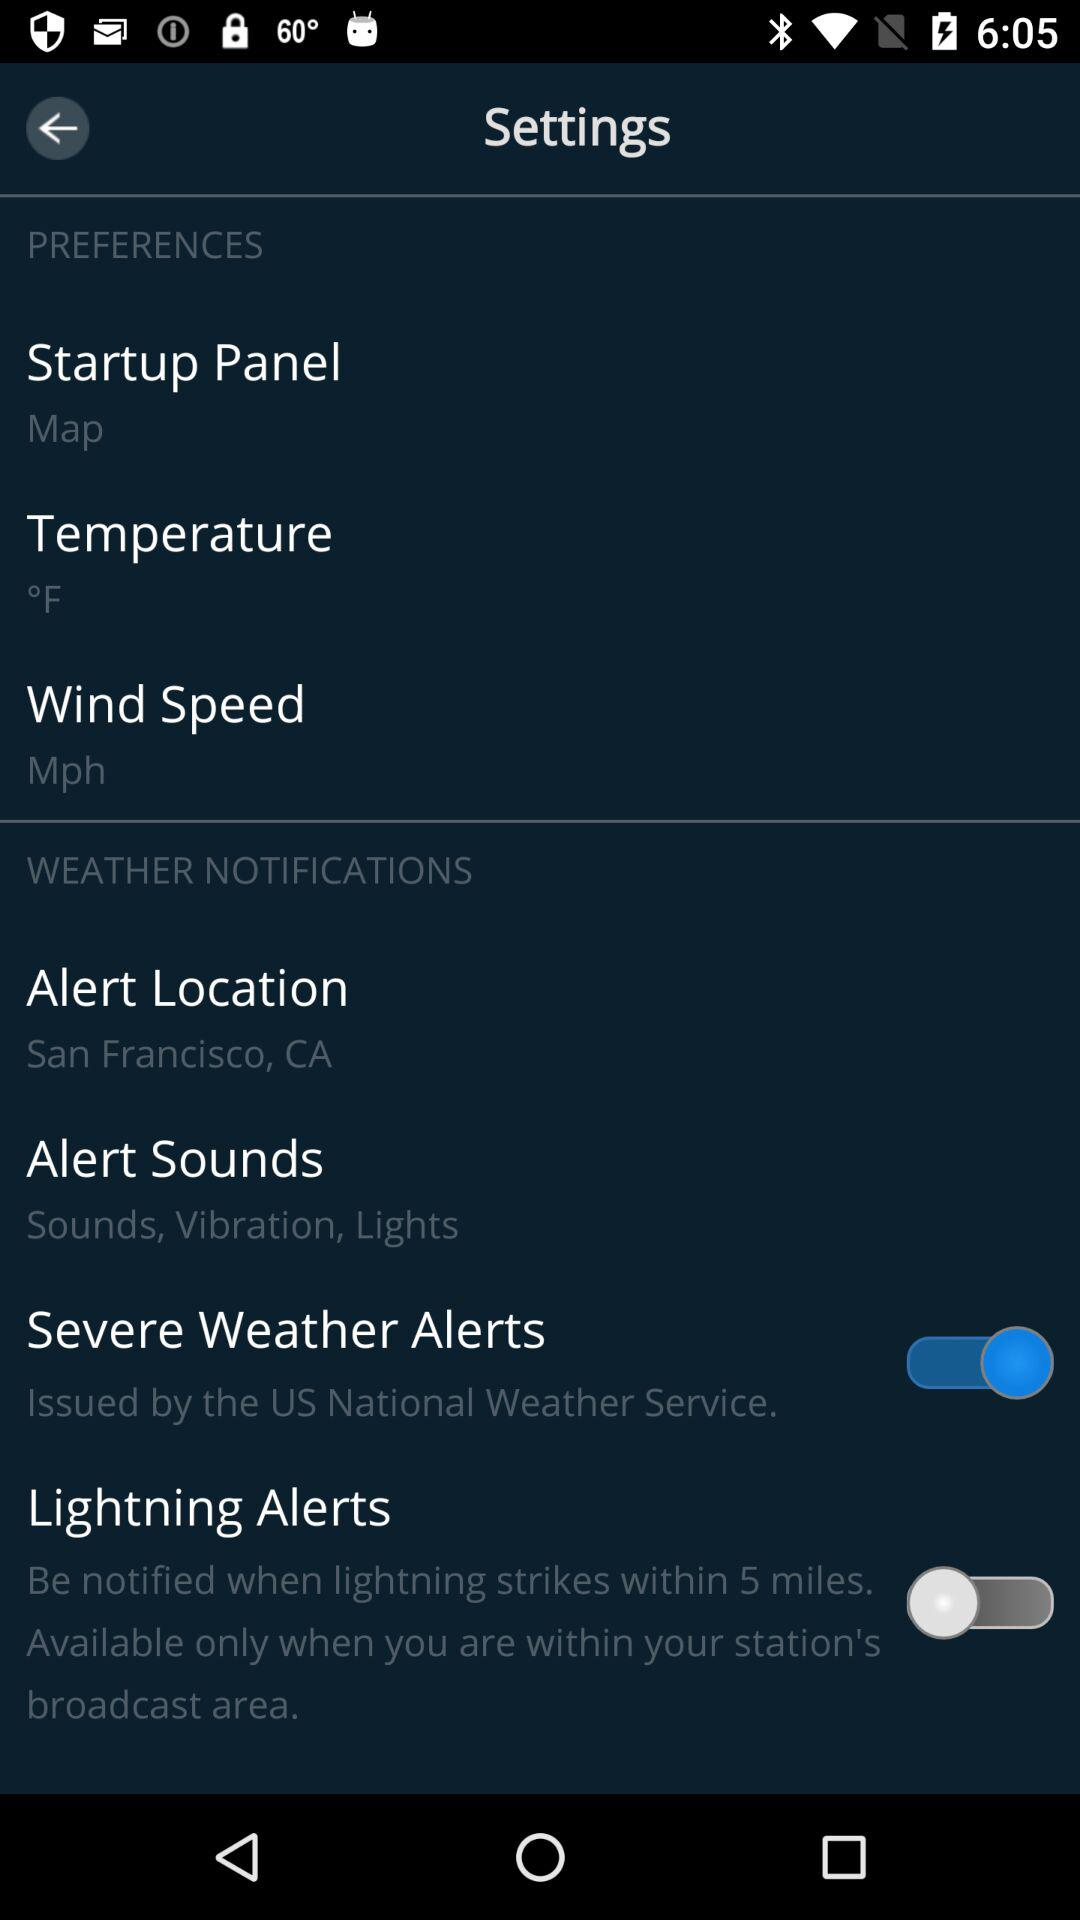What is the status of "Lightning Alerts"? The status is "off". 